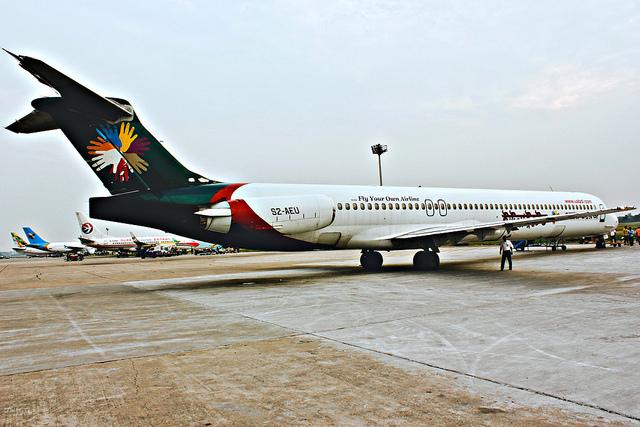What are the colors of the plane?
Keep it brief. White green and red. What is on the tail of the plane?
Give a very brief answer. Hands. How owns this plane?
Answer briefly. Airline. How many different colors does the plane have?
Answer briefly. 7. Are colors visible?
Short answer required. Yes. 